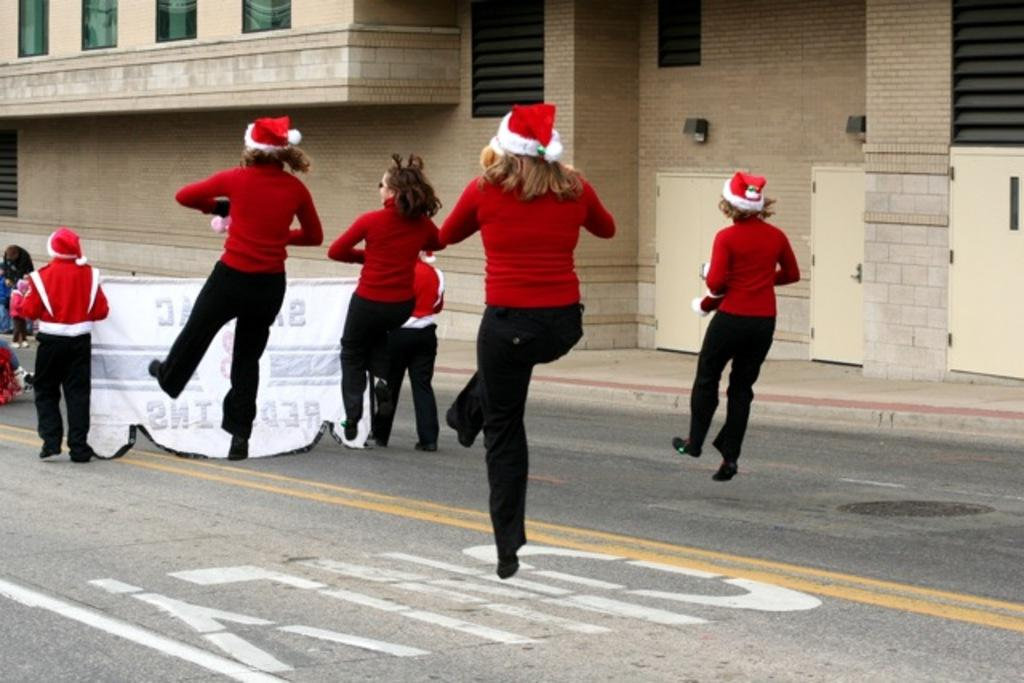What are the four persons in the image doing? The four persons in the image are jumping. What are the two standing persons doing? The two standing persons are holding a banner. What can be seen in the background of the image? There is a building in the background of the image. What type of growth can be seen on the bottle in the image? There is no bottle present in the image, so no growth can be observed. 